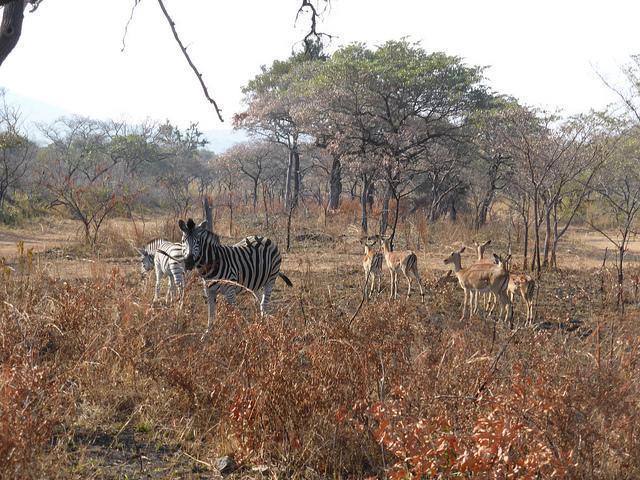How many zebras are there?
Give a very brief answer. 2. 